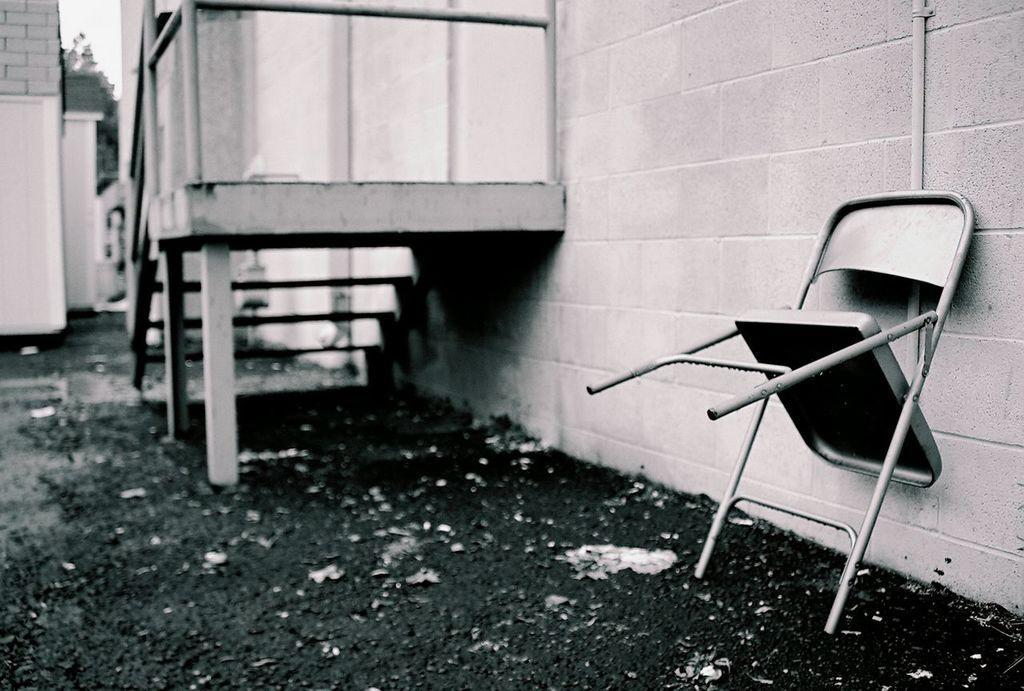Could you give a brief overview of what you see in this image? The outside picture of a house. The stairs are connected with wall. The chair is in standing position beside the wall. Far there are 2 houses with a roof top, which is made of bricks. The wall is in white color. Far there are trees. The sky is in white color. 